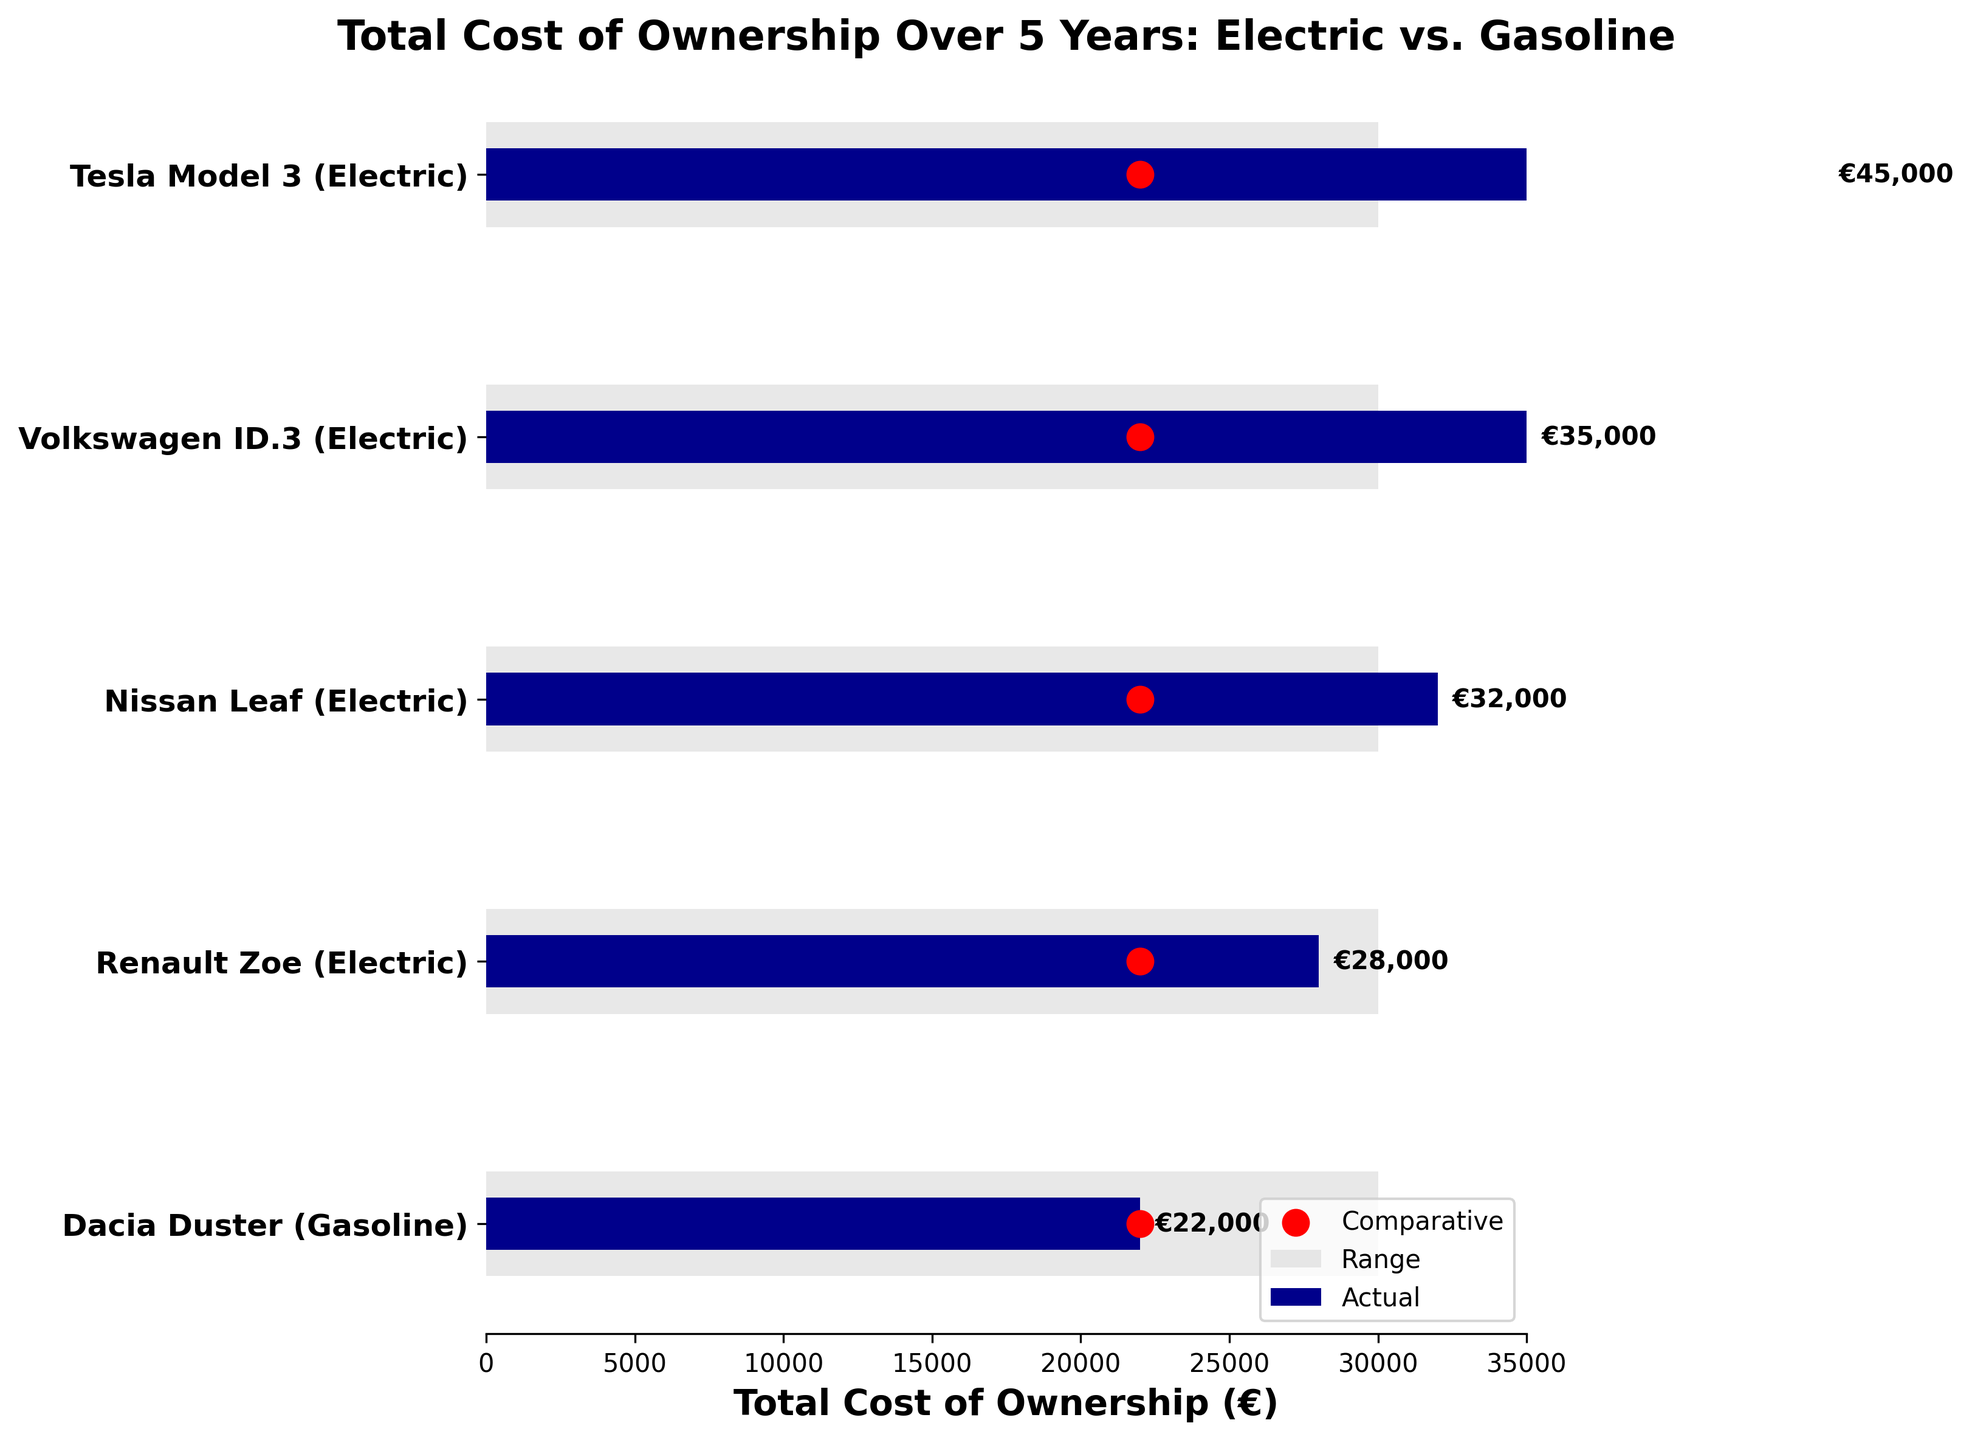What's the title of the figure? The title is at the top of the figure and summarizes the main content.
Answer: Total Cost of Ownership Over 5 Years: Electric vs. Gasoline What is the total cost of ownership for the Tesla Model 3 over 5 years? Refer to the horizontal bar labeled "Tesla Model 3 (Electric)" and find the end of the blue bar. The label next to it gives the cost.
Answer: €45,000 Which vehicle has the lowest total cost of ownership? Compare the lengths of the blue bars for all vehicles and identify the shortest one. The Dacia Duster (Gasoline) has the shortest blue bar.
Answer: Dacia Duster (Gasoline) What is the range of costs shown for the total cost of ownership? Look at the range bars in light grey to identify the minimum and maximum values. The range starts at 0 and ends at 30,000.
Answer: €0 - 30,000 How much more expensive is the total cost of ownership for the Volkswagen ID.3 compared to the Dacia Duster? Subtract the total cost of the Dacia Duster (€22,000) from the total cost of the Volkswagen ID.3 (€35,000): \(35,000 - 22,000\)
Answer: €13,000 What is the average total cost of ownership for all electric vehicles over 5 years? Sum the costs for Renault Zoe (€28,000), Nissan Leaf (€32,000), Volkswagen ID.3 (€35,000), and Tesla Model 3 (€45,000). Then divide by 4: \((28,000 + 32,000 + 35,000 + 45,000) / 4\)
Answer: €35,000 Is there any electric vehicle with a total cost of ownership lower than the comparative value (€22,000)? Compare each electric vehicle's total cost value against €22,000. None of the electric vehicles have a total cost lower than €22,000.
Answer: No Which electric vehicle has the highest total cost of ownership? Identify the electric vehicle with the longest blue bar. The Tesla Model 3 (Electric) has the highest total cost.
Answer: Tesla Model 3 (Electric) How does the total cost of ownership for the Renault Zoe compare with the comparative value? The total cost of the Renault Zoe (€28,000) is compared directly to the comparative value (€22,000), making the Renault Zoe more expensive.
Answer: €6,000 more expensive 